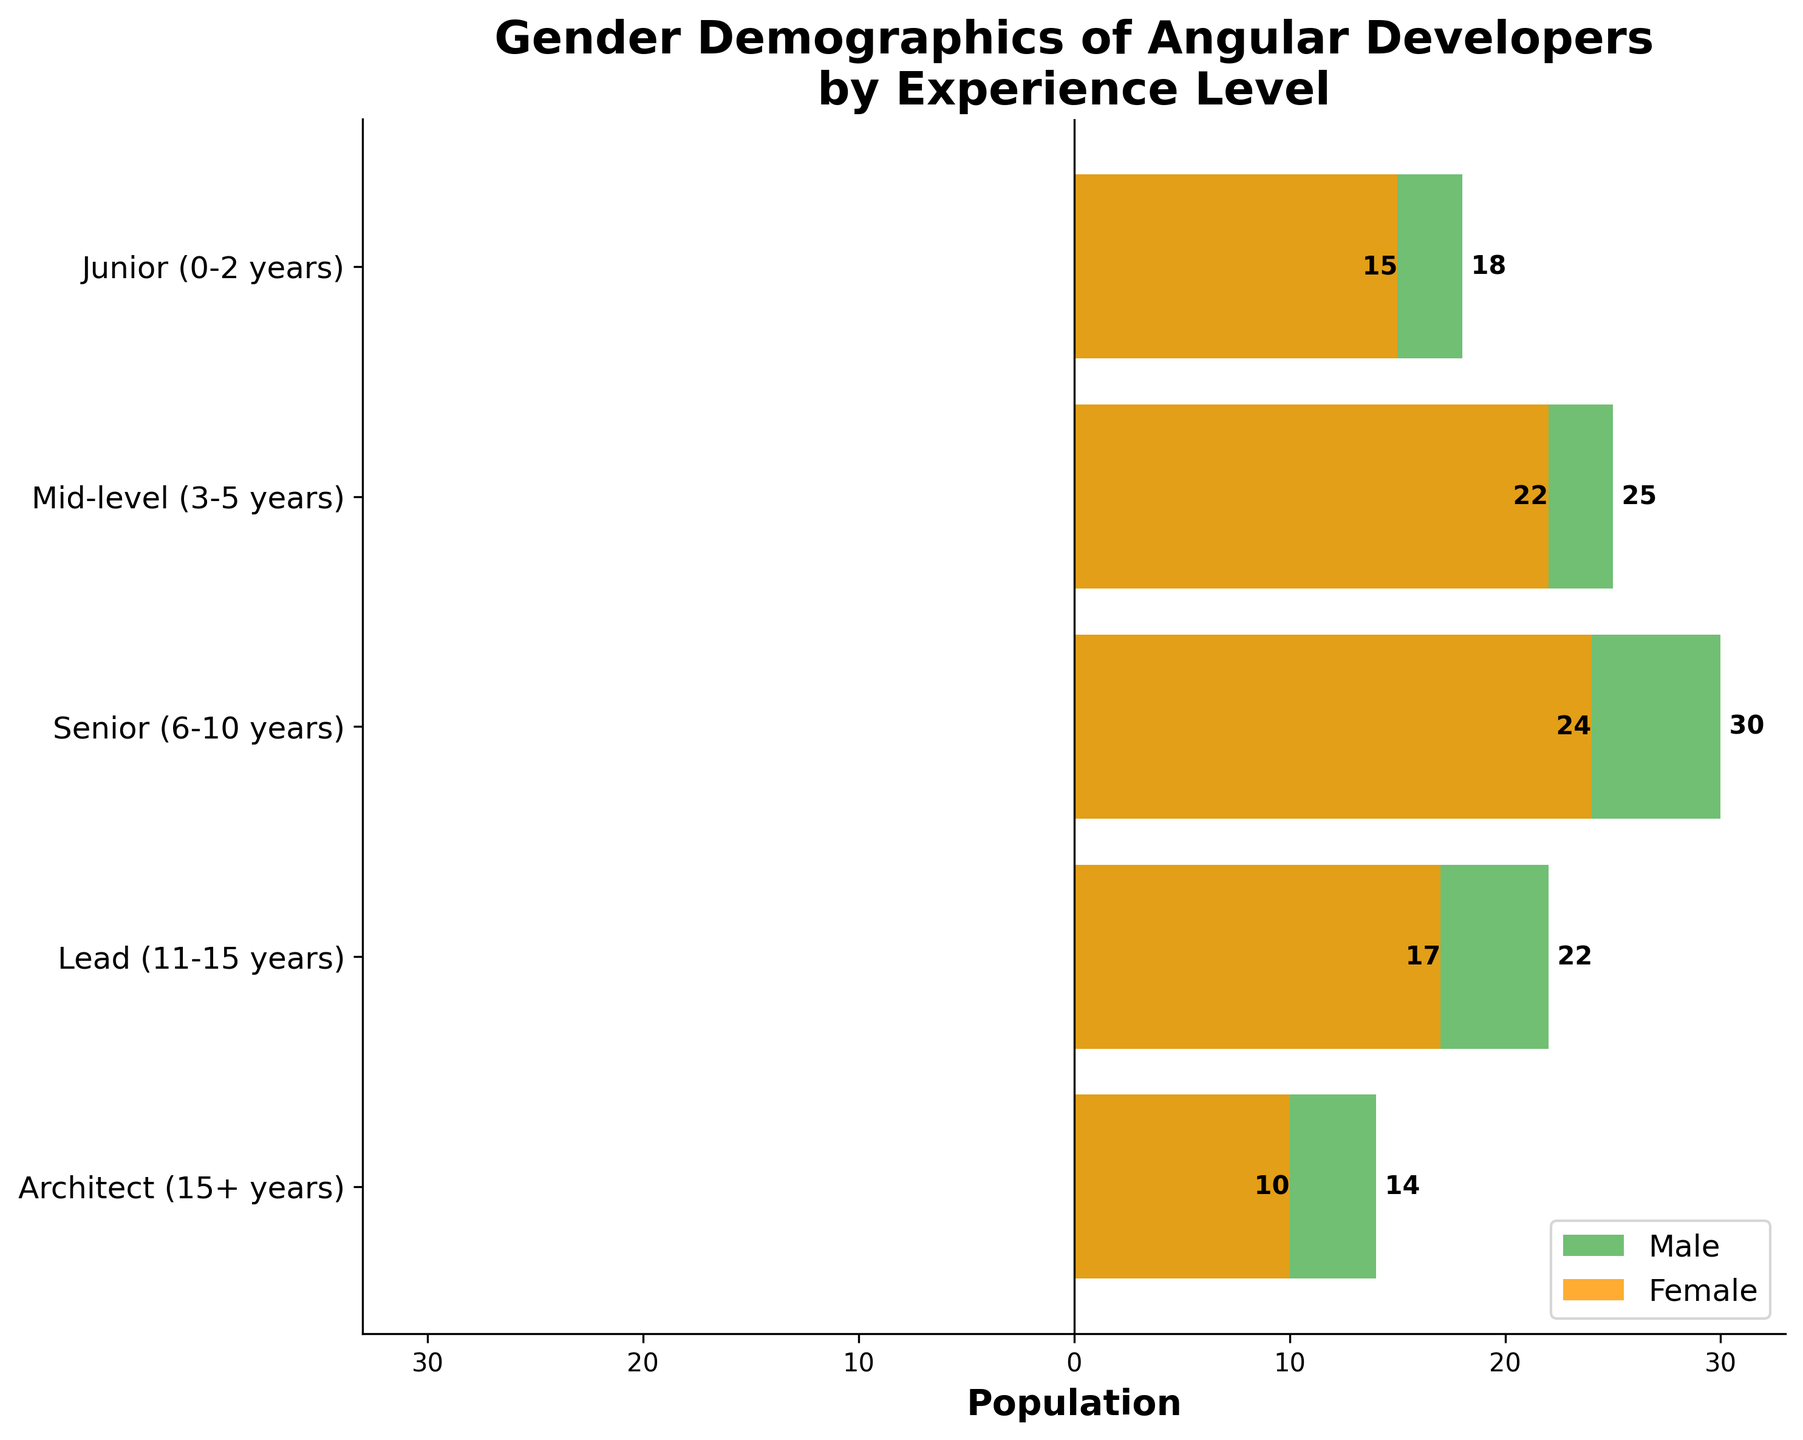What's the title of the plot? The plot's title is displayed at the top and provides a summary of the visual representation.
Answer: Gender Demographics of Angular Developers by Experience Level What does the x-axis represent? The x-axis indicates the numerical representation of the population. Positive numbers are for males, and negative numbers are for females.
Answer: Population How many experience levels are depicted in the plot? Each y-tick label represents a unique experience level; we can count these labels.
Answer: 5 Which experience level has the highest number of male Angular developers? By tracing the longest green bar (representing males) to its corresponding y-tick label, we identify the experience level.
Answer: Senior (6-10 years) Which gender has a larger population at the 'Junior (0-2 years)' experience level? Compare the lengths of the green bar (male) and the orange bar (female) for the 'Junior' level by their absolute values.
Answer: Male What is the total number of female Angular developers across all experience levels? Sum the absolute values of the female populations across all levels: 15 + 22 + 24 + 17 + 10.
Answer: 88 What is the population difference between male and female developers at the 'Lead (11-15 years)' level? Take the male population and subtract the absolute value of the female population: 22 - 17.
Answer: 5 Which experience level shows the smallest gender gap? Calculate the absolute difference between male and female populations at each level and find the smallest difference.
Answer: Lead (11-15 years) How does the population of mid-level male developers compare to senior female developers? Compare the values: 25 (mid-level males) and 24 (senior females).
Answer: Mid-level males slightly higher Which experience level shows a declining trend in both male and female developers? Check sequential experience levels and identify where both populations decrease: leads to architect level.
Answer: Architect (15+ years) 